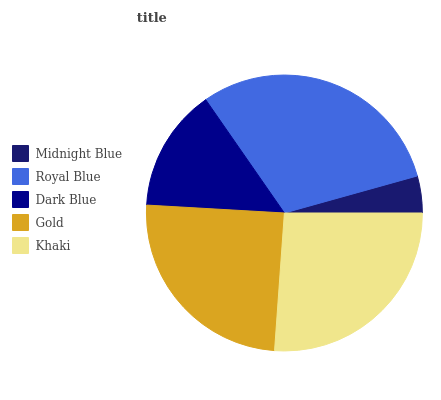Is Midnight Blue the minimum?
Answer yes or no. Yes. Is Royal Blue the maximum?
Answer yes or no. Yes. Is Dark Blue the minimum?
Answer yes or no. No. Is Dark Blue the maximum?
Answer yes or no. No. Is Royal Blue greater than Dark Blue?
Answer yes or no. Yes. Is Dark Blue less than Royal Blue?
Answer yes or no. Yes. Is Dark Blue greater than Royal Blue?
Answer yes or no. No. Is Royal Blue less than Dark Blue?
Answer yes or no. No. Is Gold the high median?
Answer yes or no. Yes. Is Gold the low median?
Answer yes or no. Yes. Is Midnight Blue the high median?
Answer yes or no. No. Is Khaki the low median?
Answer yes or no. No. 